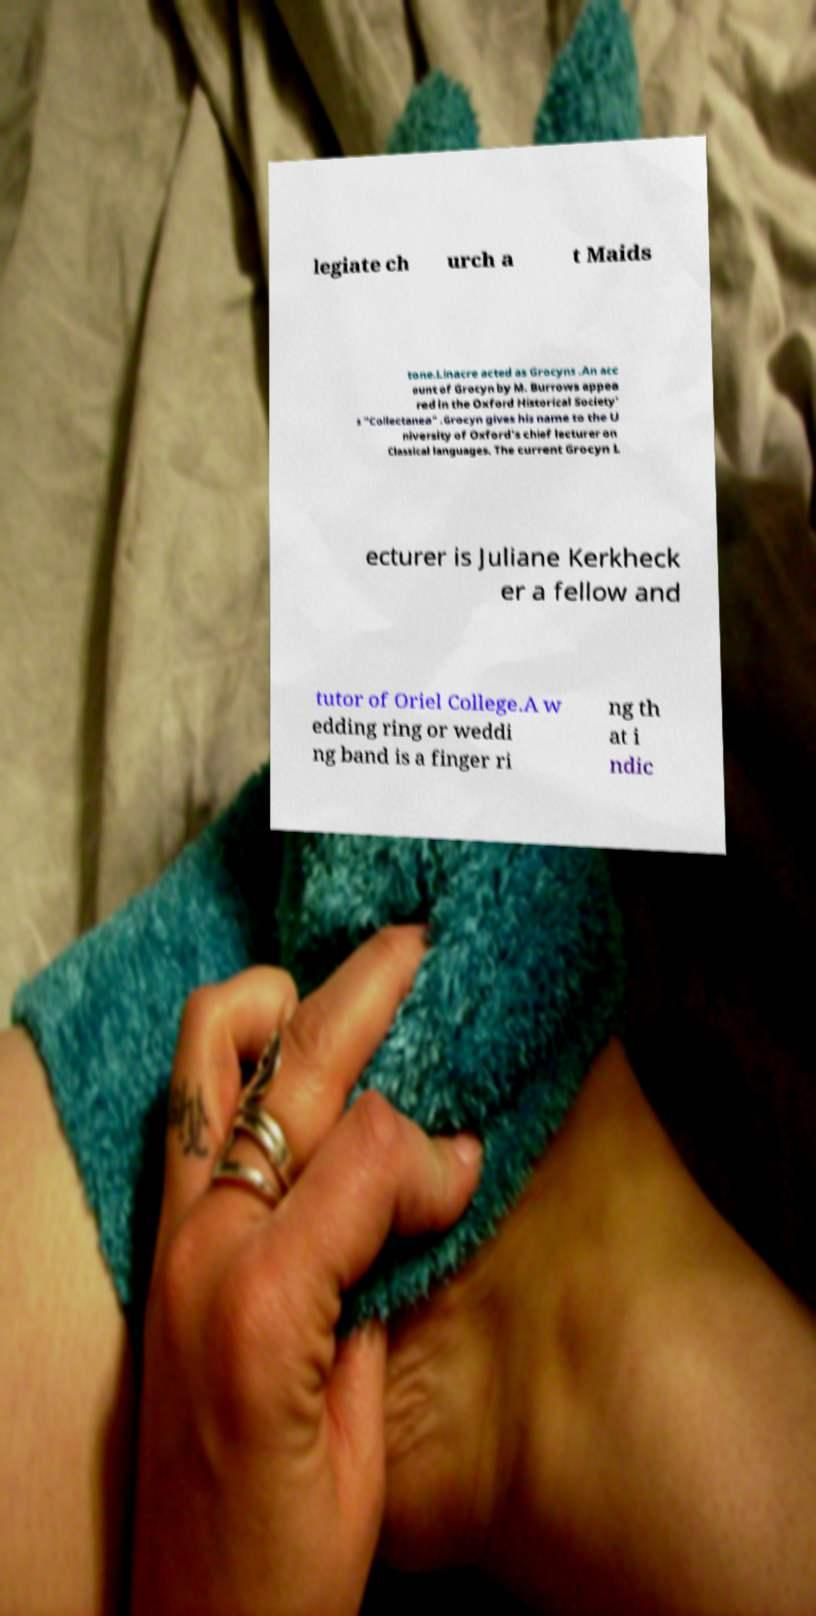Please identify and transcribe the text found in this image. legiate ch urch a t Maids tone.Linacre acted as Grocyns .An acc ount of Grocyn by M. Burrows appea red in the Oxford Historical Society' s "Collectanea" .Grocyn gives his name to the U niversity of Oxford's chief lecturer on Classical languages. The current Grocyn L ecturer is Juliane Kerkheck er a fellow and tutor of Oriel College.A w edding ring or weddi ng band is a finger ri ng th at i ndic 